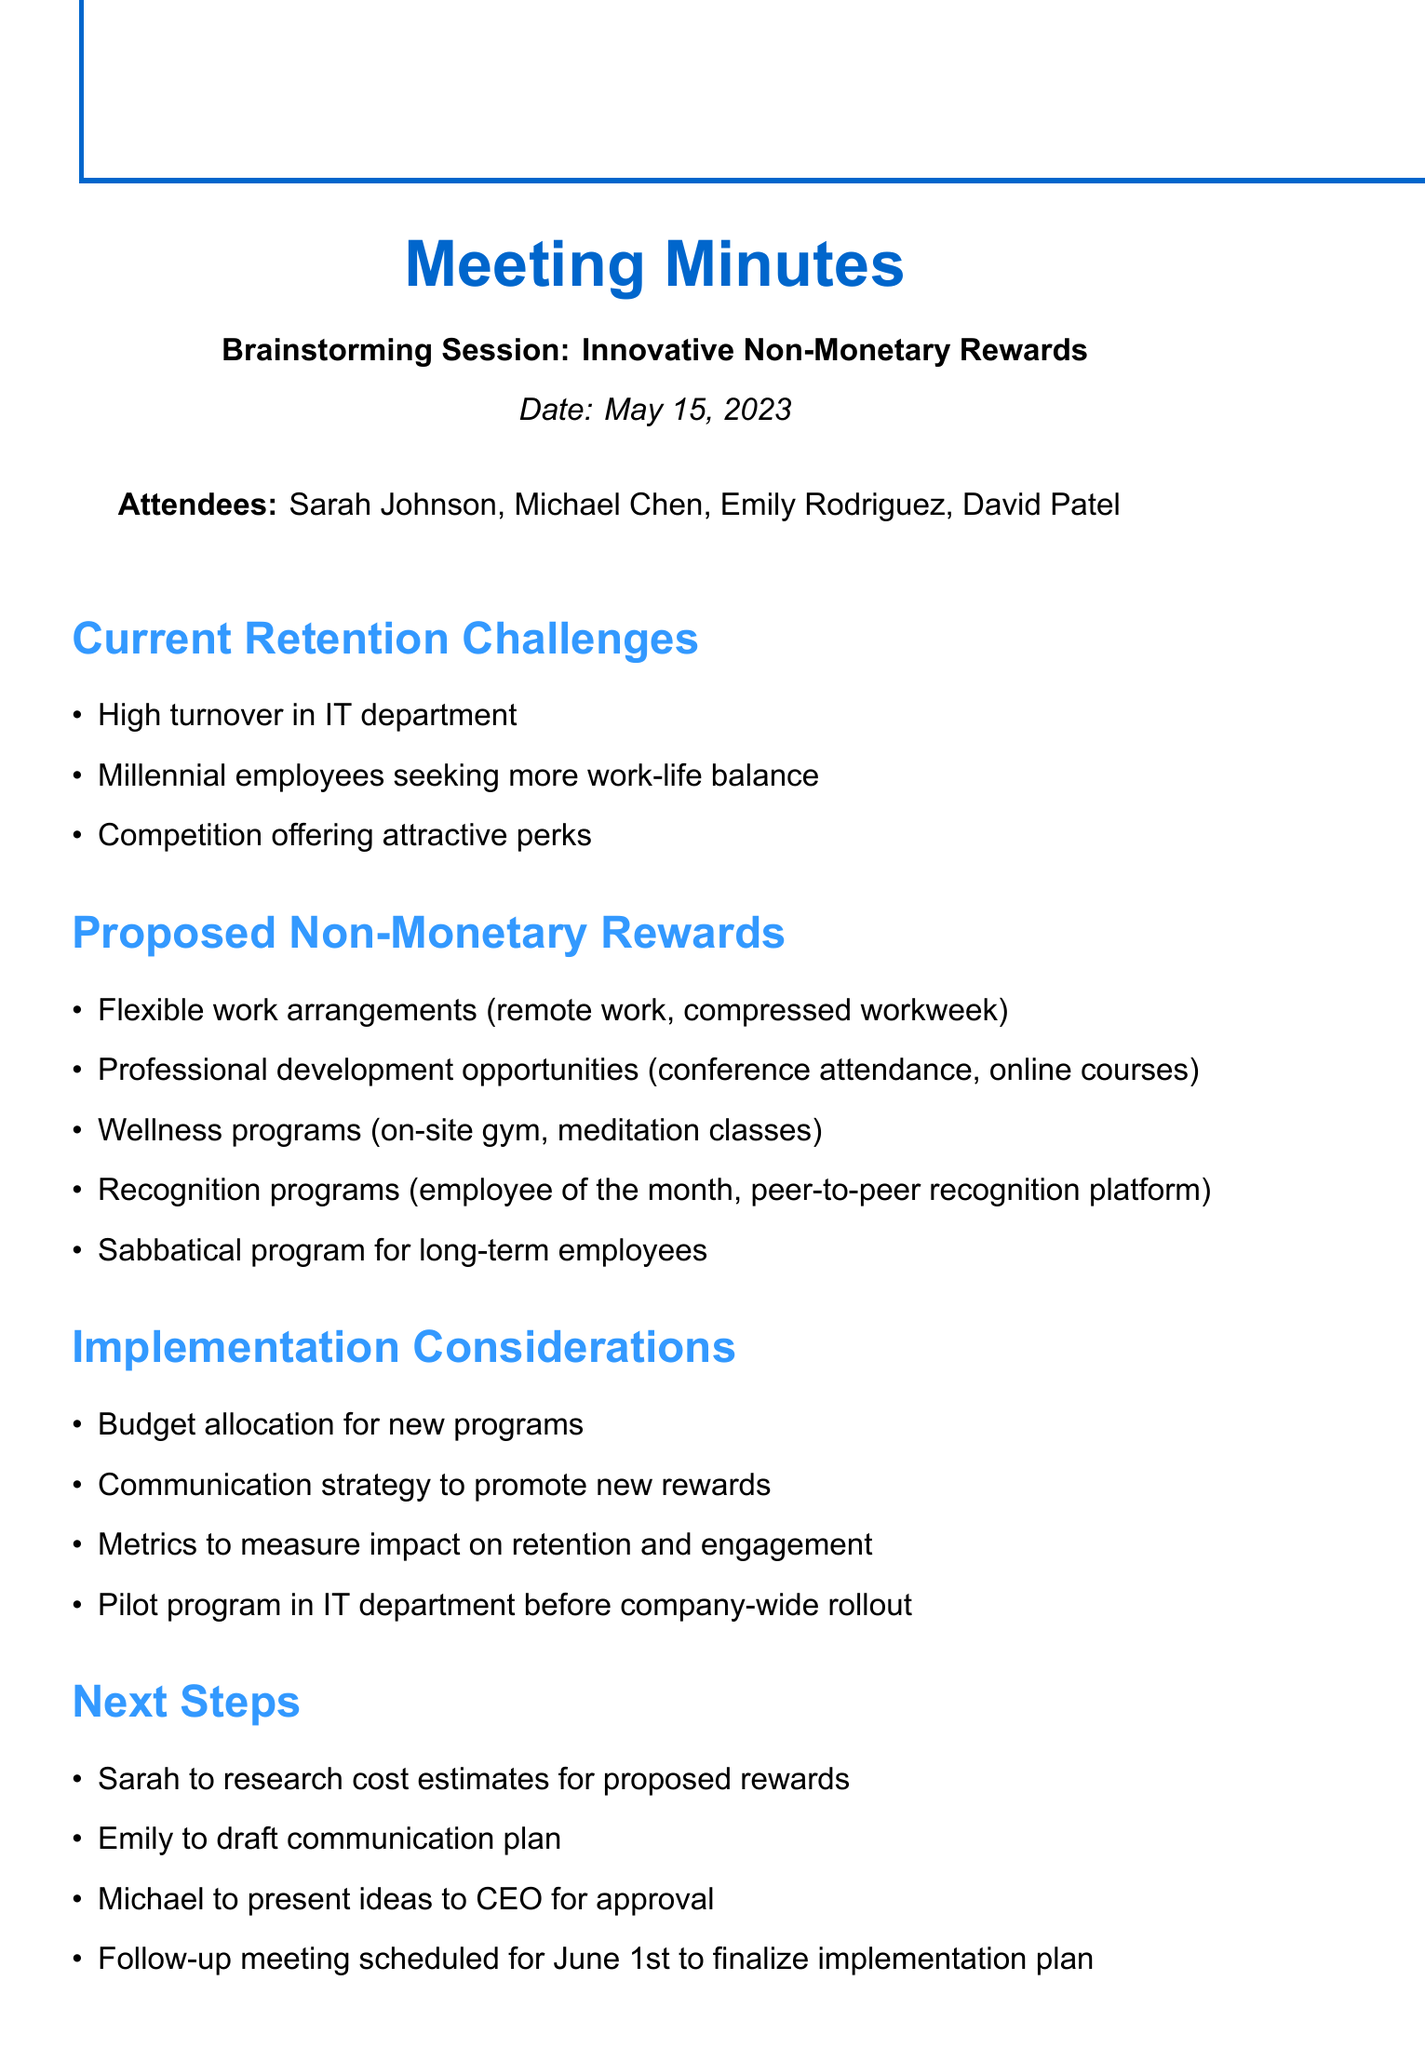What is the date of the meeting? The date of the meeting is explicitly stated in the document section.
Answer: May 15, 2023 Who is the Employee Engagement Manager? The document lists the attendees and identifies Emily Rodriguez as the Employee Engagement Manager.
Answer: Emily Rodriguez What are the proposed non-monetary rewards? The document outlines specific non-monetary rewards under the proposed section.
Answer: Flexible work arrangements, Professional development opportunities, Wellness programs, Recognition programs, Sabbatical program What is one of the current retention challenges mentioned? The document provides a specific point regarding challenges faced in retention in the current section.
Answer: High turnover in IT department Who is responsible for researching cost estimates? The next steps section assigns specific tasks to attendees, clearly identifying responsibilities.
Answer: Sarah What is the communication strategy's purpose? The implementation considerations section details the importance of a communication strategy in promoting new rewards, indicating its significance.
Answer: Promote new rewards What is the follow-up meeting date? The document specifies the date for the next meeting in the next steps section.
Answer: June 1st Why is a pilot program recommended? The implementation considerations highlight the need for a pilot program prior to a wider rollout, demonstrating a careful approach to implementation.
Answer: Before company-wide rollout 